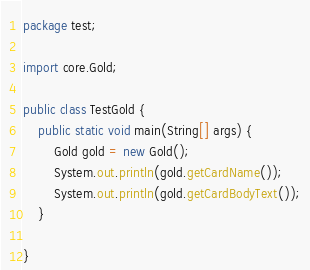Convert code to text. <code><loc_0><loc_0><loc_500><loc_500><_Java_>package test;

import core.Gold;

public class TestGold {
	public static void main(String[] args) {
		Gold gold = new Gold();
		System.out.println(gold.getCardName());
		System.out.println(gold.getCardBodyText());
	}

}
</code> 